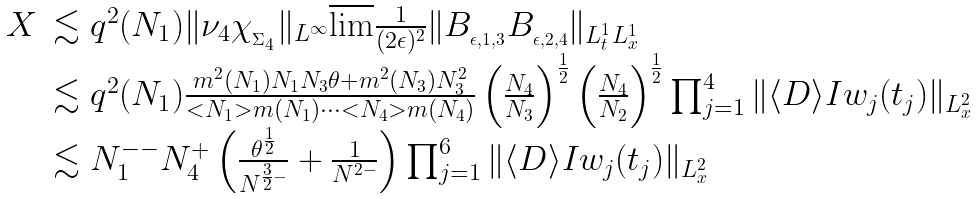Convert formula to latex. <formula><loc_0><loc_0><loc_500><loc_500>\begin{array} { l l } X & \lesssim q ^ { 2 } ( N _ { 1 } ) \| \nu _ { 4 } \chi _ { _ { \Sigma _ { 4 } } } \| _ { L ^ { \infty } } \overline { \lim } \frac { 1 } { ( 2 \epsilon ) ^ { 2 } } \| B _ { _ { \epsilon , 1 , 3 } } B _ { _ { \epsilon , 2 , 4 } } \| _ { L ^ { 1 } _ { t } L ^ { 1 } _ { x } } \\ & \lesssim q ^ { 2 } ( N _ { 1 } ) \frac { m ^ { 2 } ( N _ { 1 } ) N _ { 1 } N _ { 3 } \theta + m ^ { 2 } ( N _ { 3 } ) N _ { 3 } ^ { 2 } } { < N _ { 1 } > m ( N _ { 1 } ) \dots < N _ { 4 } > m ( N _ { 4 } ) } \left ( \frac { N _ { 4 } } { N _ { 3 } } \right ) ^ { \frac { 1 } { 2 } } \left ( \frac { N _ { 4 } } { N _ { 2 } } \right ) ^ { \frac { 1 } { 2 } } \prod _ { j = 1 } ^ { 4 } \| \langle D \rangle I w _ { j } ( t _ { j } ) \| _ { L _ { x } ^ { 2 } } \\ & \lesssim N _ { 1 } ^ { - - } N _ { 4 } ^ { + } \left ( \frac { \theta ^ { \frac { 1 } { 2 } } } { N ^ { \frac { 3 } { 2 } - } } + \frac { 1 } { N ^ { 2 - } } \right ) \prod _ { j = 1 } ^ { 6 } \| \langle D \rangle I w _ { j } ( t _ { j } ) \| _ { L _ { x } ^ { 2 } } \end{array}</formula> 